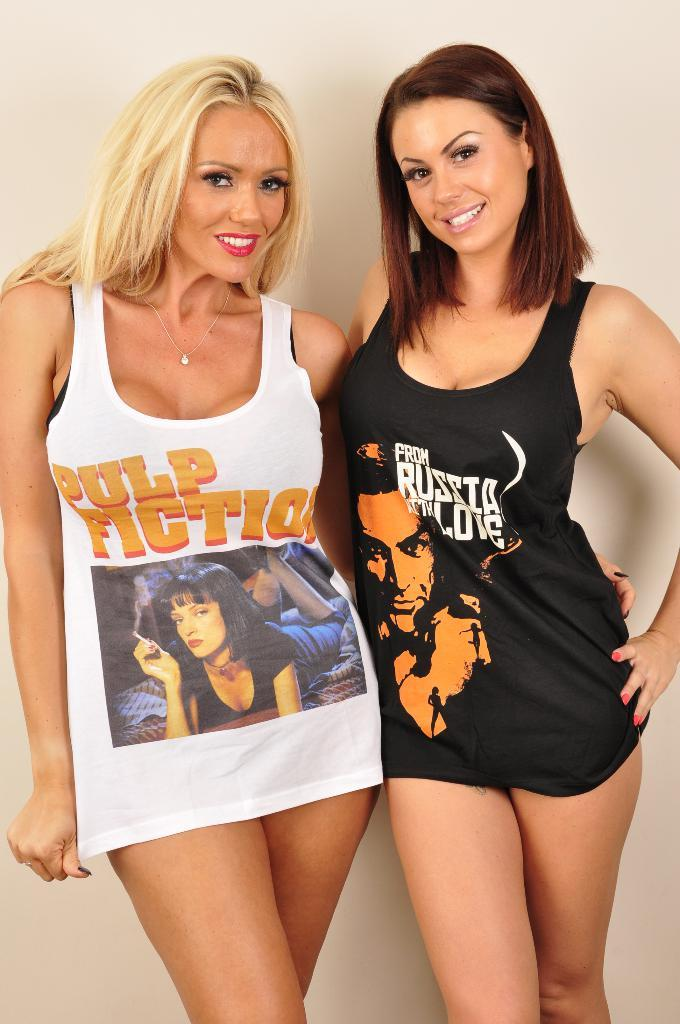How many people are in the image? There are two women in the image. What are the women doing in the image? The women are standing and smiling. What are the women looking at? The women are looking at something, but it is not visible in the image. What can be seen in the background of the image? There is a wall visible in the background of the image. What type of hair product is the woman on the left using in the image? There is no hair product visible in the image, as the focus is on the women standing and smiling. 